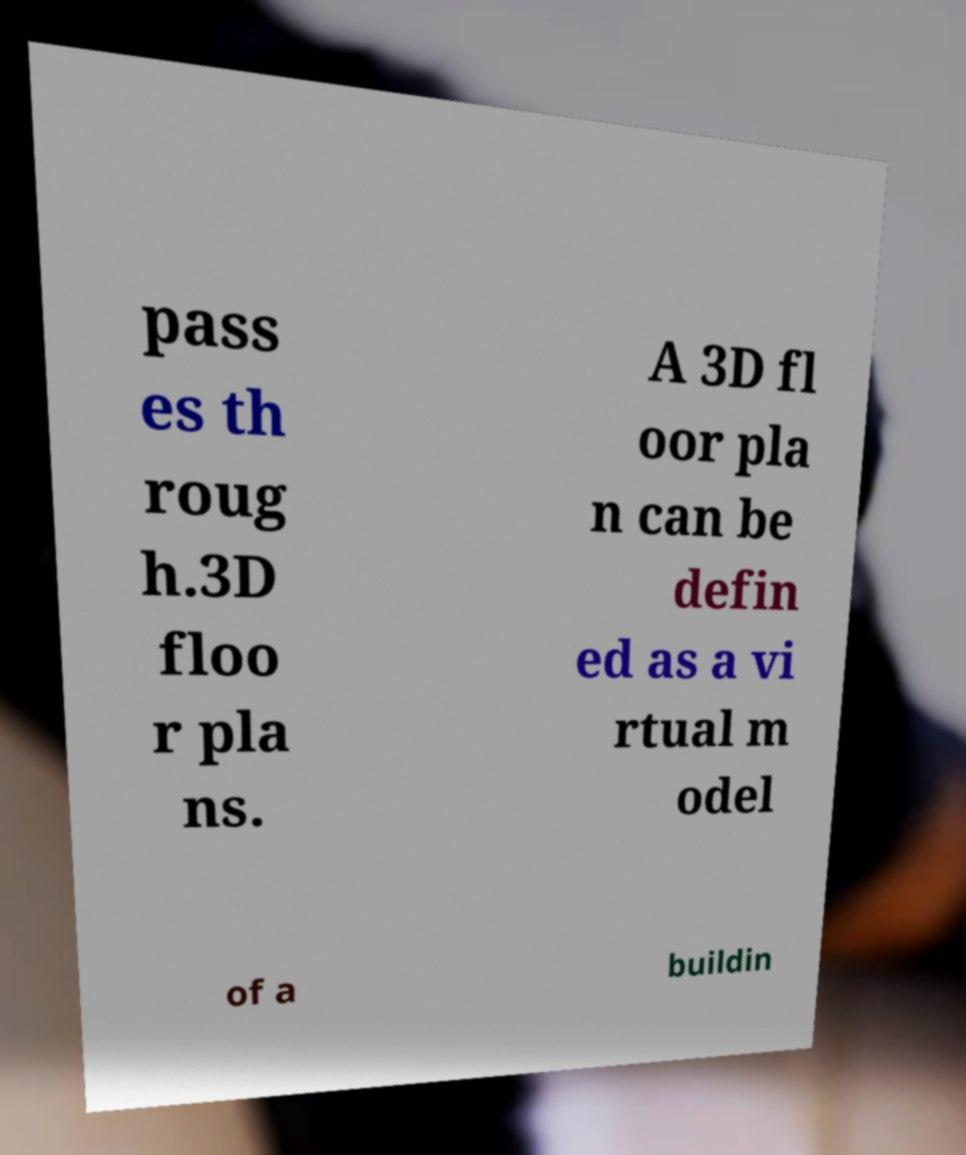What messages or text are displayed in this image? I need them in a readable, typed format. pass es th roug h.3D floo r pla ns. A 3D fl oor pla n can be defin ed as a vi rtual m odel of a buildin 